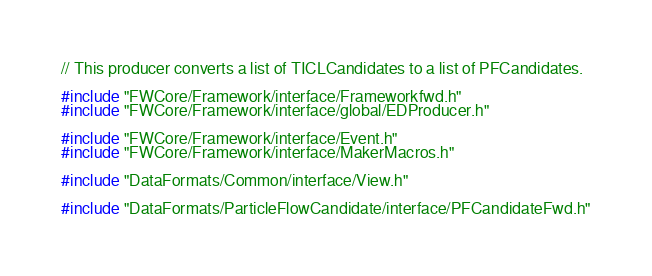<code> <loc_0><loc_0><loc_500><loc_500><_C++_>// This producer converts a list of TICLCandidates to a list of PFCandidates.

#include "FWCore/Framework/interface/Frameworkfwd.h"
#include "FWCore/Framework/interface/global/EDProducer.h"

#include "FWCore/Framework/interface/Event.h"
#include "FWCore/Framework/interface/MakerMacros.h"

#include "DataFormats/Common/interface/View.h"

#include "DataFormats/ParticleFlowCandidate/interface/PFCandidateFwd.h"</code> 